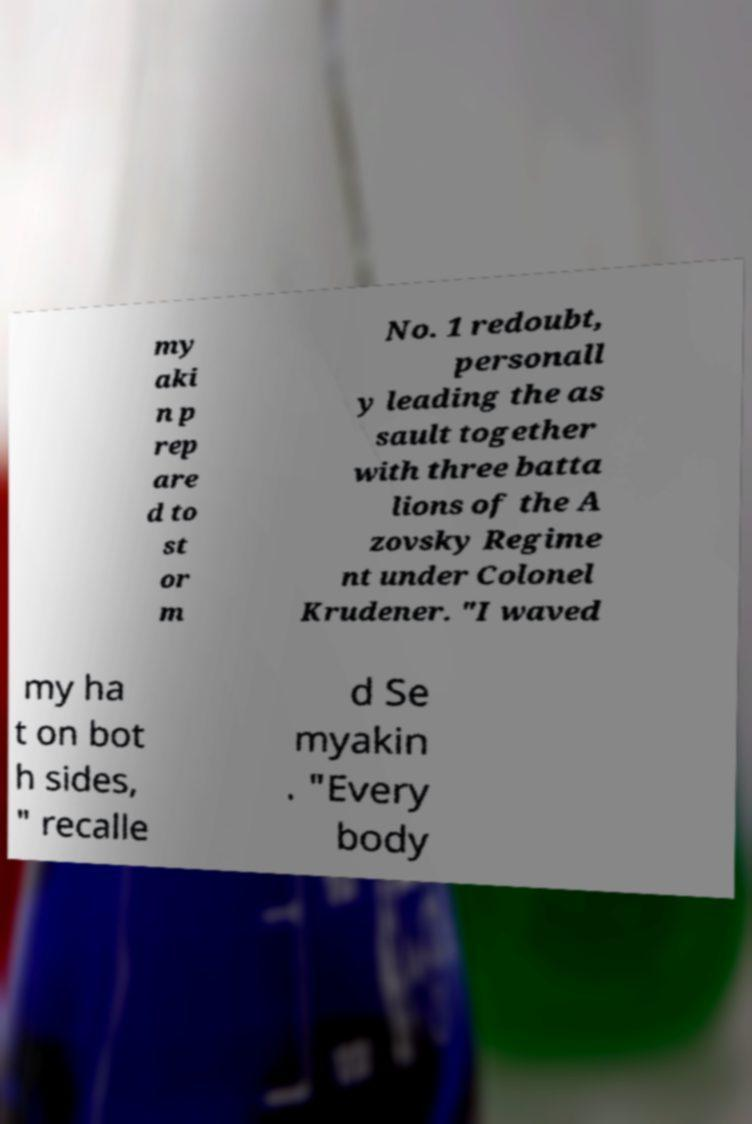Can you accurately transcribe the text from the provided image for me? my aki n p rep are d to st or m No. 1 redoubt, personall y leading the as sault together with three batta lions of the A zovsky Regime nt under Colonel Krudener. "I waved my ha t on bot h sides, " recalle d Se myakin . "Every body 